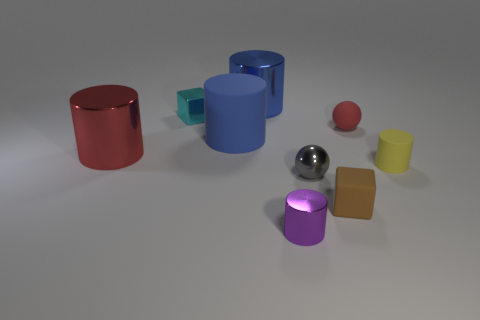How many objects in the image are spherical? There are two spherical objects in the image, one is red and the other is silver. 